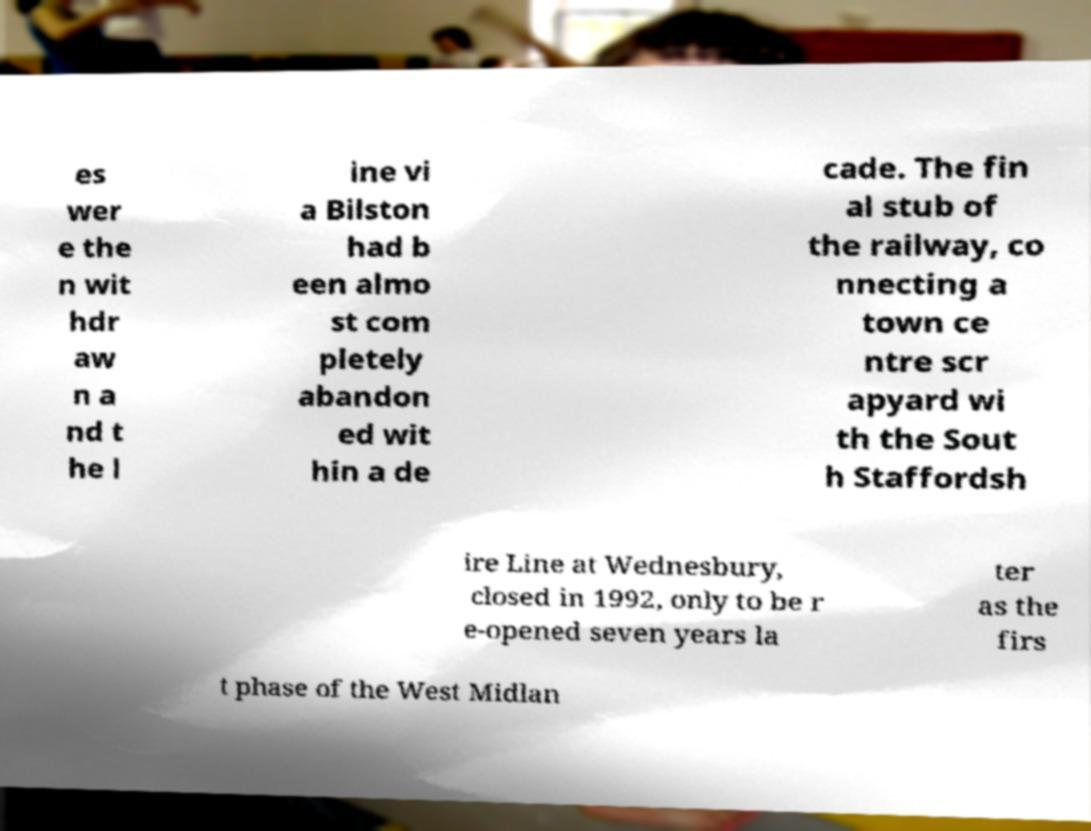Can you accurately transcribe the text from the provided image for me? es wer e the n wit hdr aw n a nd t he l ine vi a Bilston had b een almo st com pletely abandon ed wit hin a de cade. The fin al stub of the railway, co nnecting a town ce ntre scr apyard wi th the Sout h Staffordsh ire Line at Wednesbury, closed in 1992, only to be r e-opened seven years la ter as the firs t phase of the West Midlan 